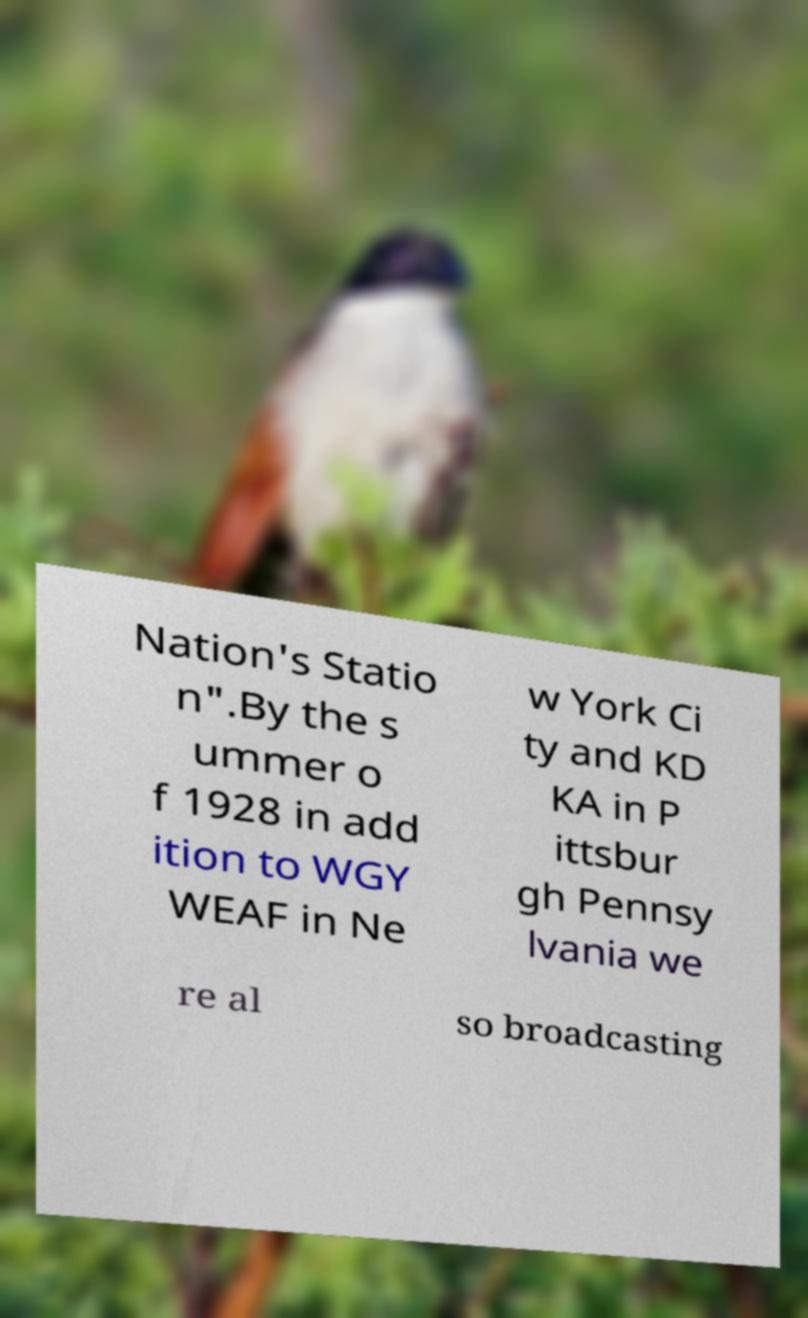What messages or text are displayed in this image? I need them in a readable, typed format. Nation's Statio n".By the s ummer o f 1928 in add ition to WGY WEAF in Ne w York Ci ty and KD KA in P ittsbur gh Pennsy lvania we re al so broadcasting 